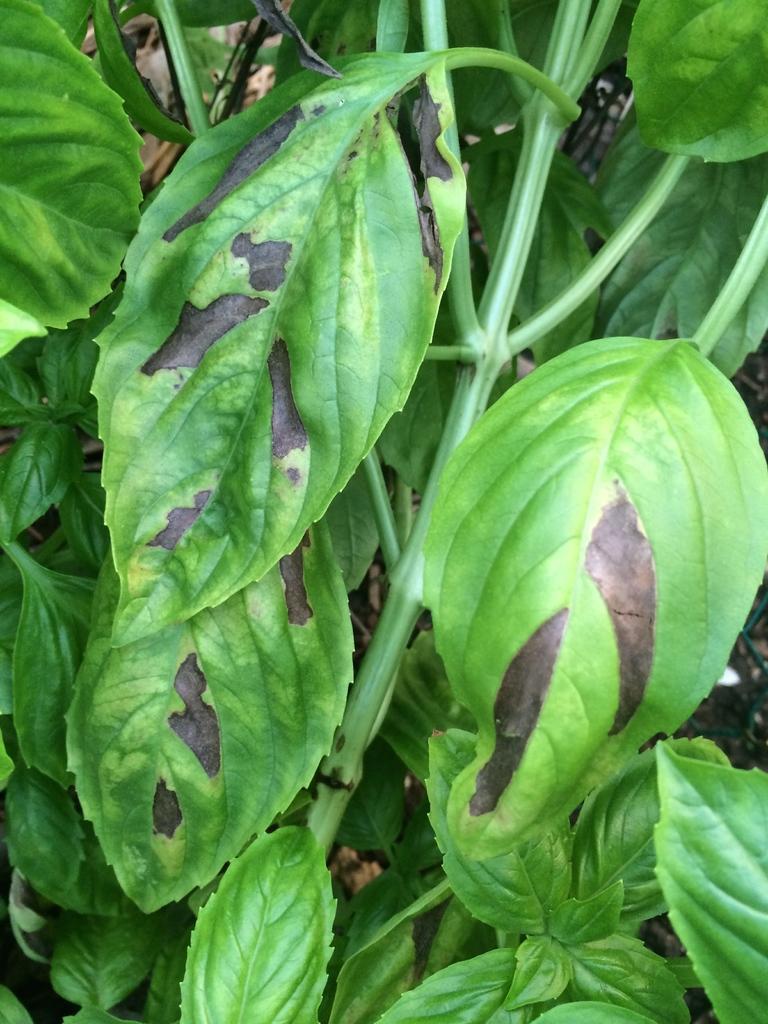Please provide a concise description of this image. In the picture we can see green color leaves to the plants. 